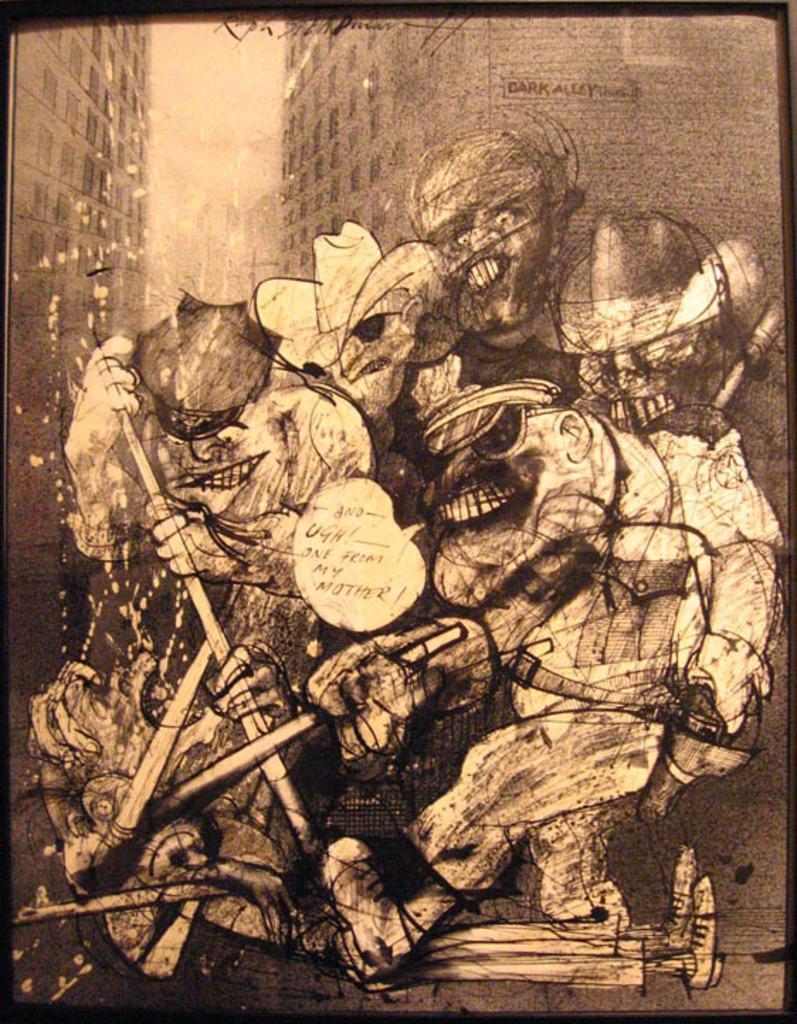Please provide a concise description of this image. In this image there is a painting. There are people standing on the land. A person is lying on the land. Background there are buildings. Right side there is a person holding the stick. 